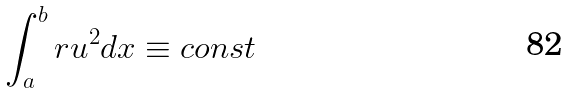<formula> <loc_0><loc_0><loc_500><loc_500>\int _ { a } ^ { b } r u ^ { 2 } d x \equiv c o n s t</formula> 